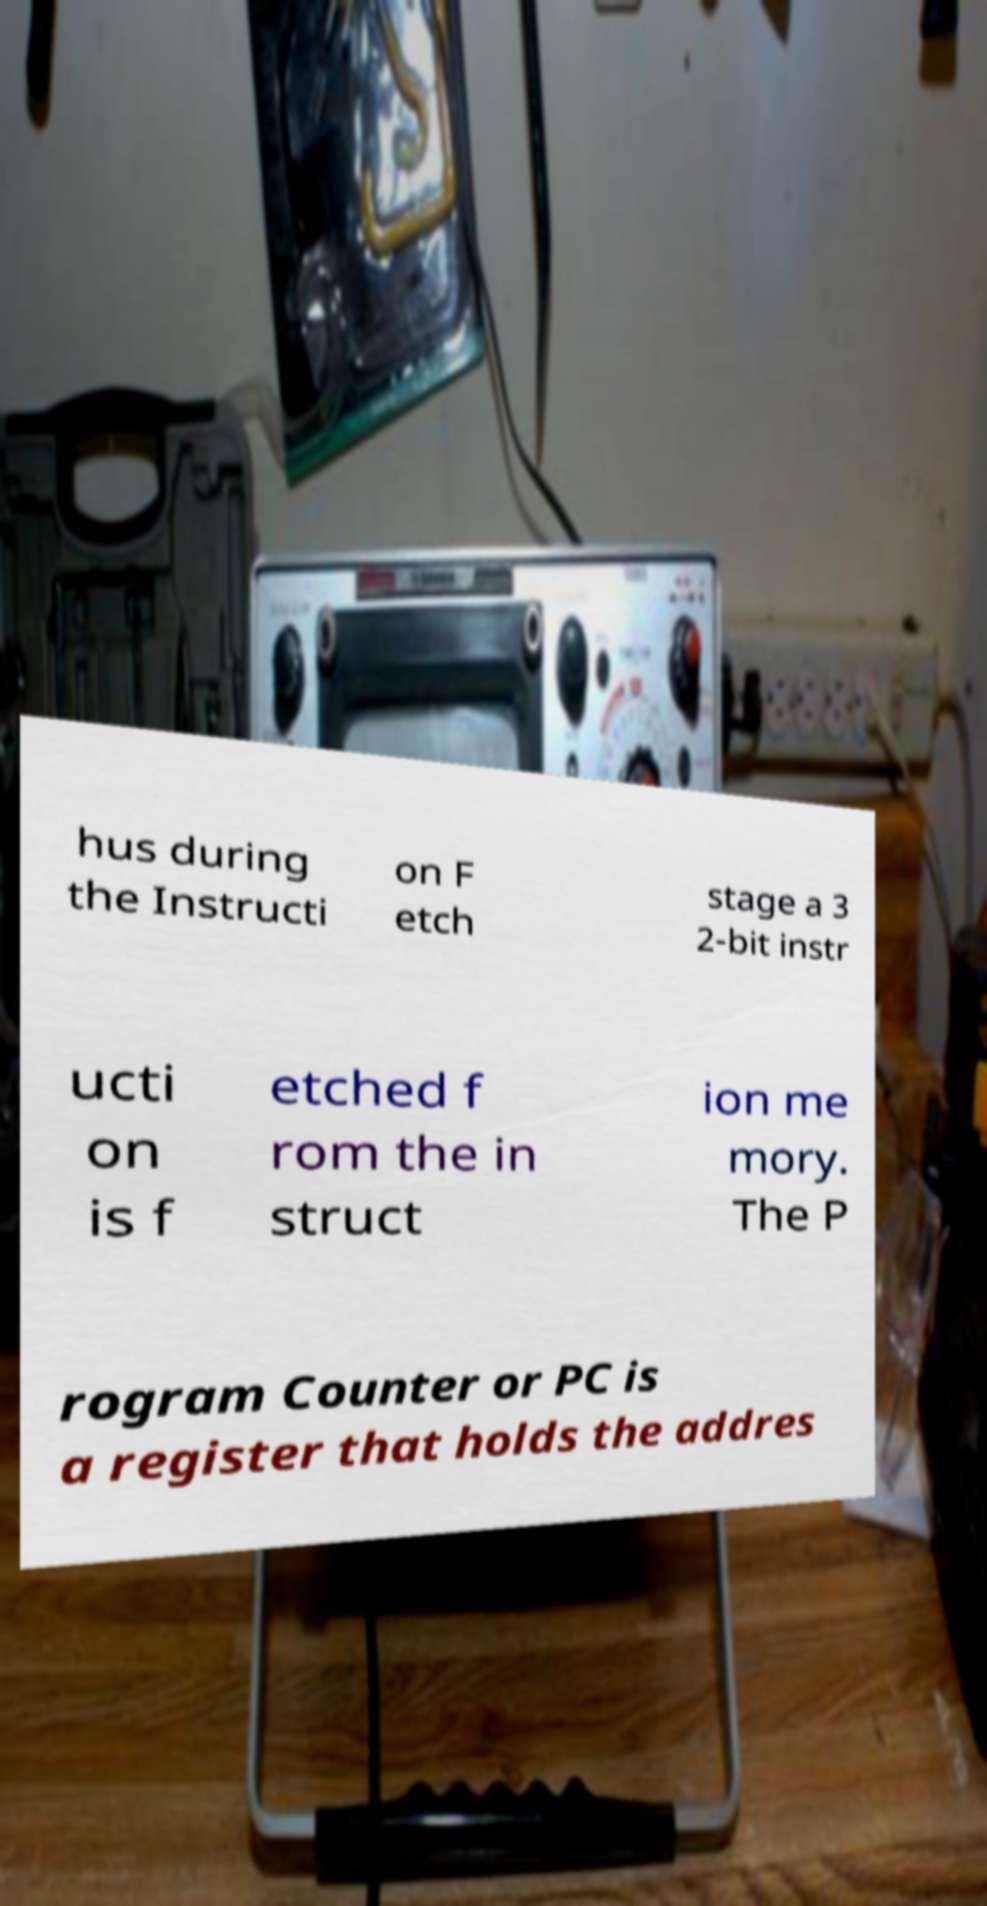I need the written content from this picture converted into text. Can you do that? hus during the Instructi on F etch stage a 3 2-bit instr ucti on is f etched f rom the in struct ion me mory. The P rogram Counter or PC is a register that holds the addres 